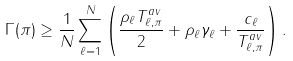<formula> <loc_0><loc_0><loc_500><loc_500>\Gamma ( \pi ) \geq \frac { 1 } { N } \sum _ { \ell = 1 } ^ { N } \left ( \frac { \rho _ { \ell } T _ { \ell , \pi } ^ { a v } } { 2 } + \rho _ { \ell } \gamma _ { \ell } + \frac { c _ { \ell } } { T _ { \ell , \pi } ^ { a v } } \right ) .</formula> 